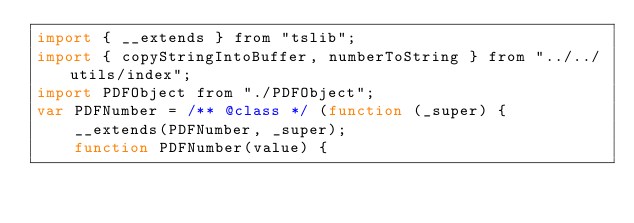<code> <loc_0><loc_0><loc_500><loc_500><_JavaScript_>import { __extends } from "tslib";
import { copyStringIntoBuffer, numberToString } from "../../utils/index";
import PDFObject from "./PDFObject";
var PDFNumber = /** @class */ (function (_super) {
    __extends(PDFNumber, _super);
    function PDFNumber(value) {</code> 